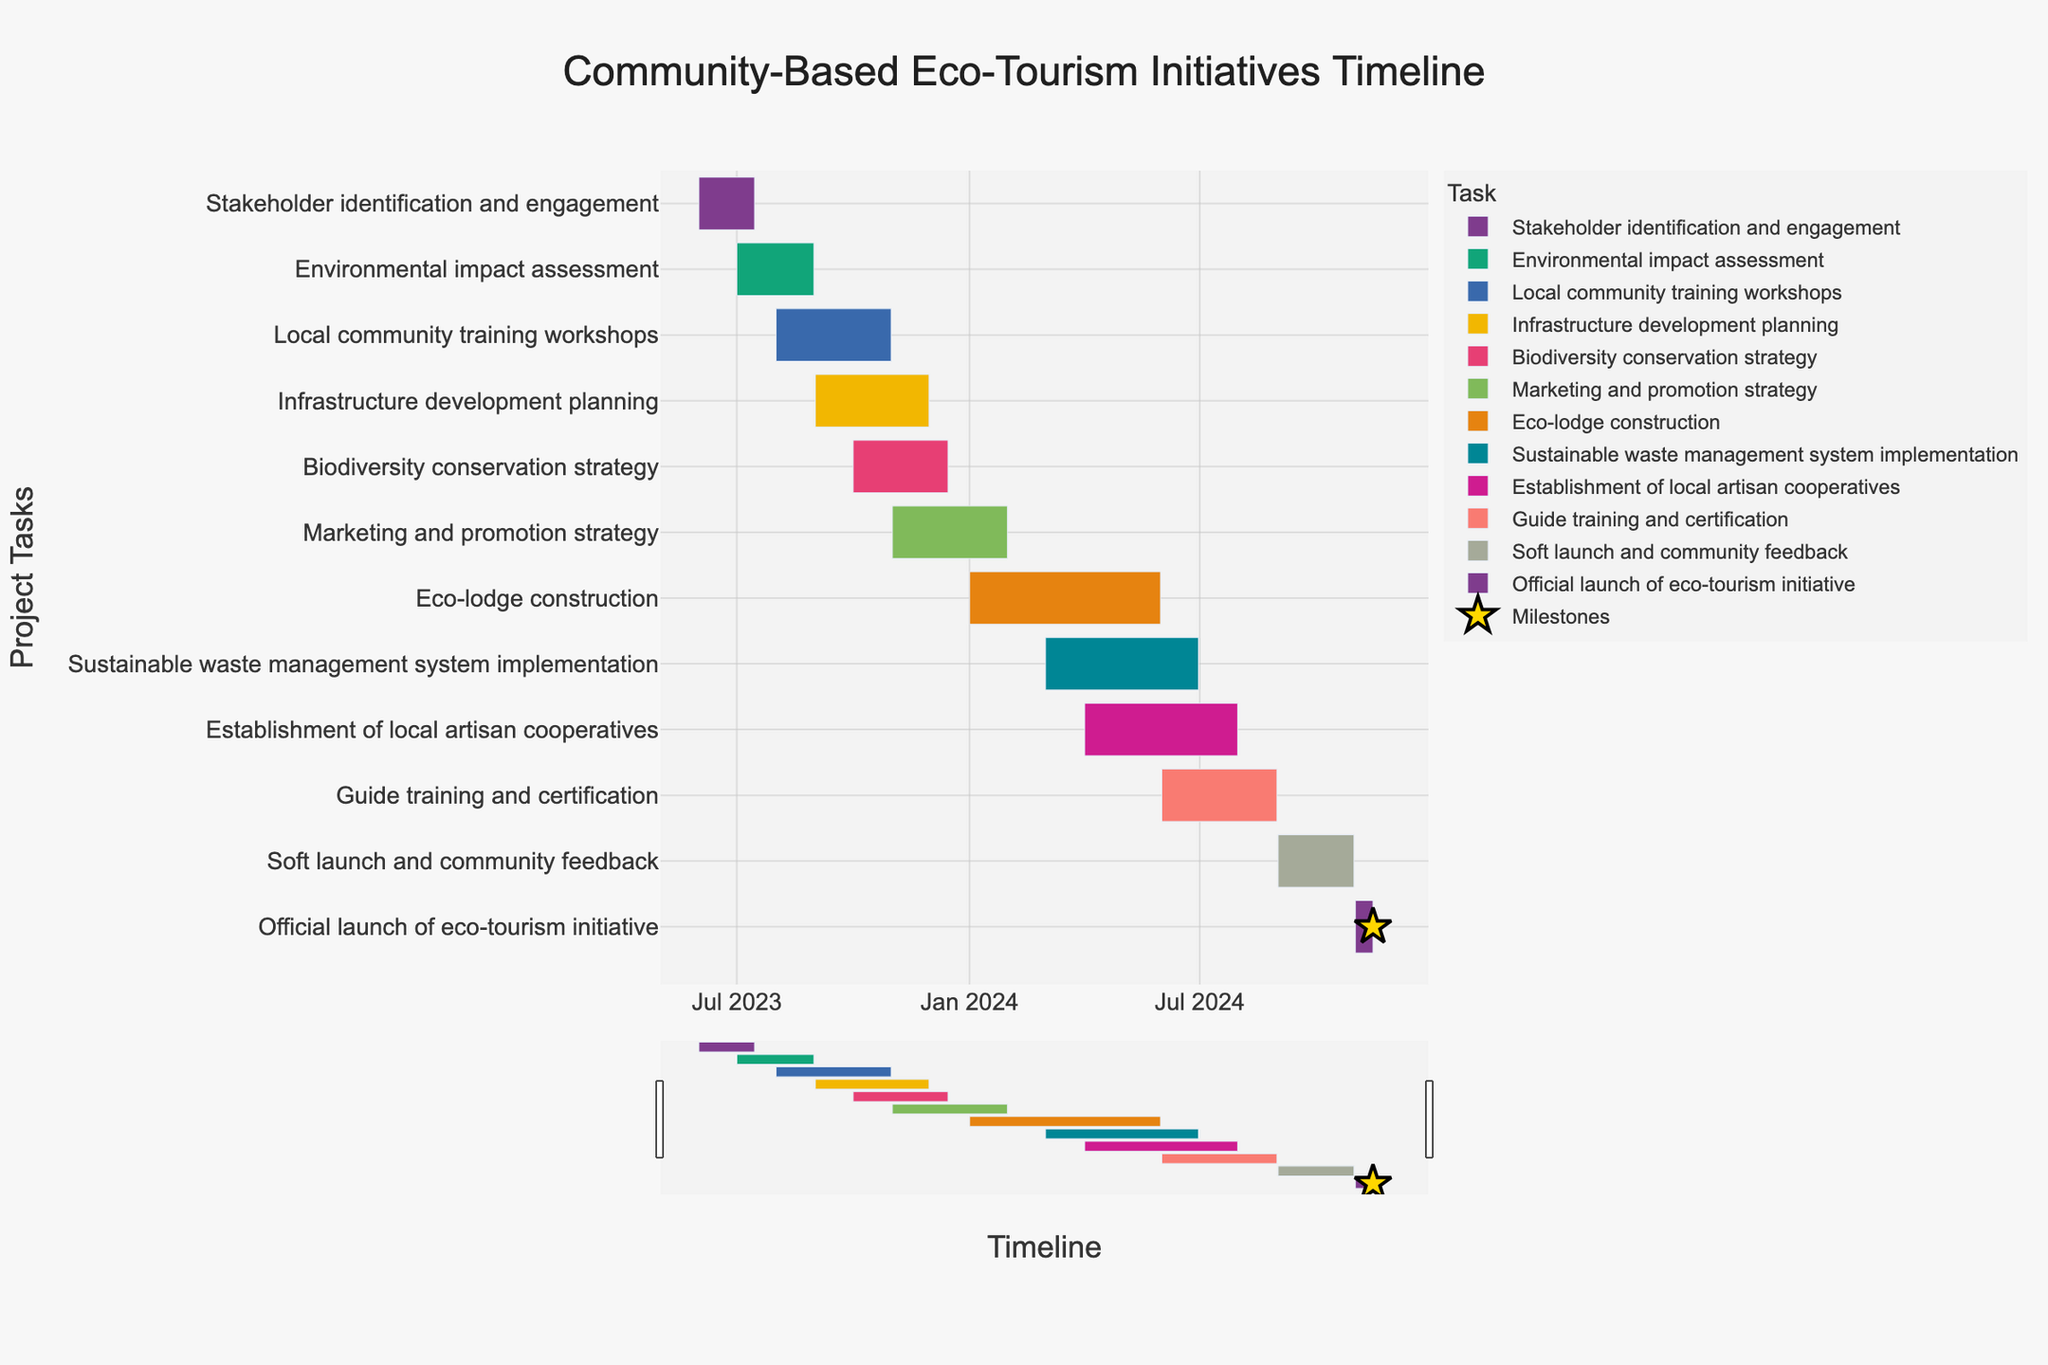What's the title of the chart? The title of the chart is usually found at the top and provides an overview of what the chart is about. In this case, it is clearly stated.
Answer: Community-Based Eco-Tourism Initiatives Timeline How long is the "Local community training workshops" task scheduled to last? The chart lists tasks along with their durations. The duration of each task can typically be seen alongside the task bar or in a hover tooltip.
Answer: 92 days Which task is scheduled to end first? By looking at the end dates of all tasks, we can determine which one finishes the earliest. The task with the earliest end date will end first. In this chart, "Stakeholder identification and engagement" ends first.
Answer: Stakeholder identification and engagement How many tasks have a duration of 92 days? By examining the chart's list of durations next to each task bar, we can count how many have a duration of 92 days.
Answer: Three tasks What is the total duration from the start of "Stakeholder identification and engagement" to the end of "Official launch of eco-tourism initiative"? We calculate the total duration from June 1, 2023, to November 15, 2024, which involves finding the difference between these dates.
Answer: 533 days During which month does "Biodiversity conservation strategy" start? The start date for each task is listed along the horizontal axis of the chart. By finding the start date of "Biodiversity conservation strategy", we see it starts in October.
Answer: October 2023 Which task has both its start and end dates falling entirely within the year 2024? We look for a task that starts and ends within the same year, specifically January 1, 2024, to December 31, 2024. "Eco-lodge construction" is one such task.
Answer: Eco-lodge construction Are there any tasks that overlap entirely with "Sustainable waste management system implementation"? To answer this, we inspect tasks that start and end within the period of March 1, 2024, to June 30, 2024. Tasks that fall entirely within these dates include "Establishment of local artisan cooperatives".
Answer: Establishment of local artisan cooperatives Which tasks are categorized as milestones? Milestones are usually marked differently in the chart, often with special symbols or markers like stars. The tasks with a duration of 15 days or less are typically considered milestones in this chart, such as "Official launch of eco-tourism initiative".
Answer: Official launch of eco-tourism initiative What is the shortest task duration shown in the chart? By reviewing the duration of each task, the task with the shortest duration will be identified. The "Official launch of eco-tourism initiative" has the shortest duration.
Answer: 15 days 